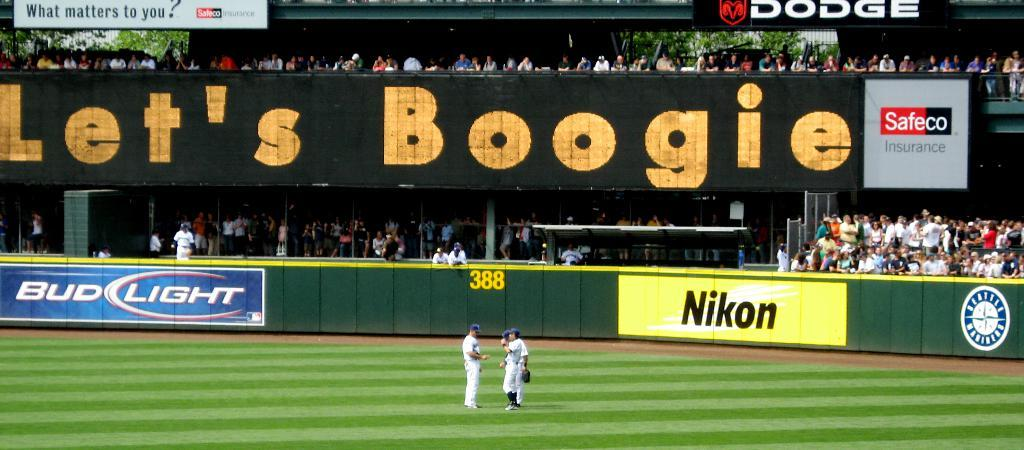Provide a one-sentence caption for the provided image. A baseball field with a Let's Boogie sign on it. 